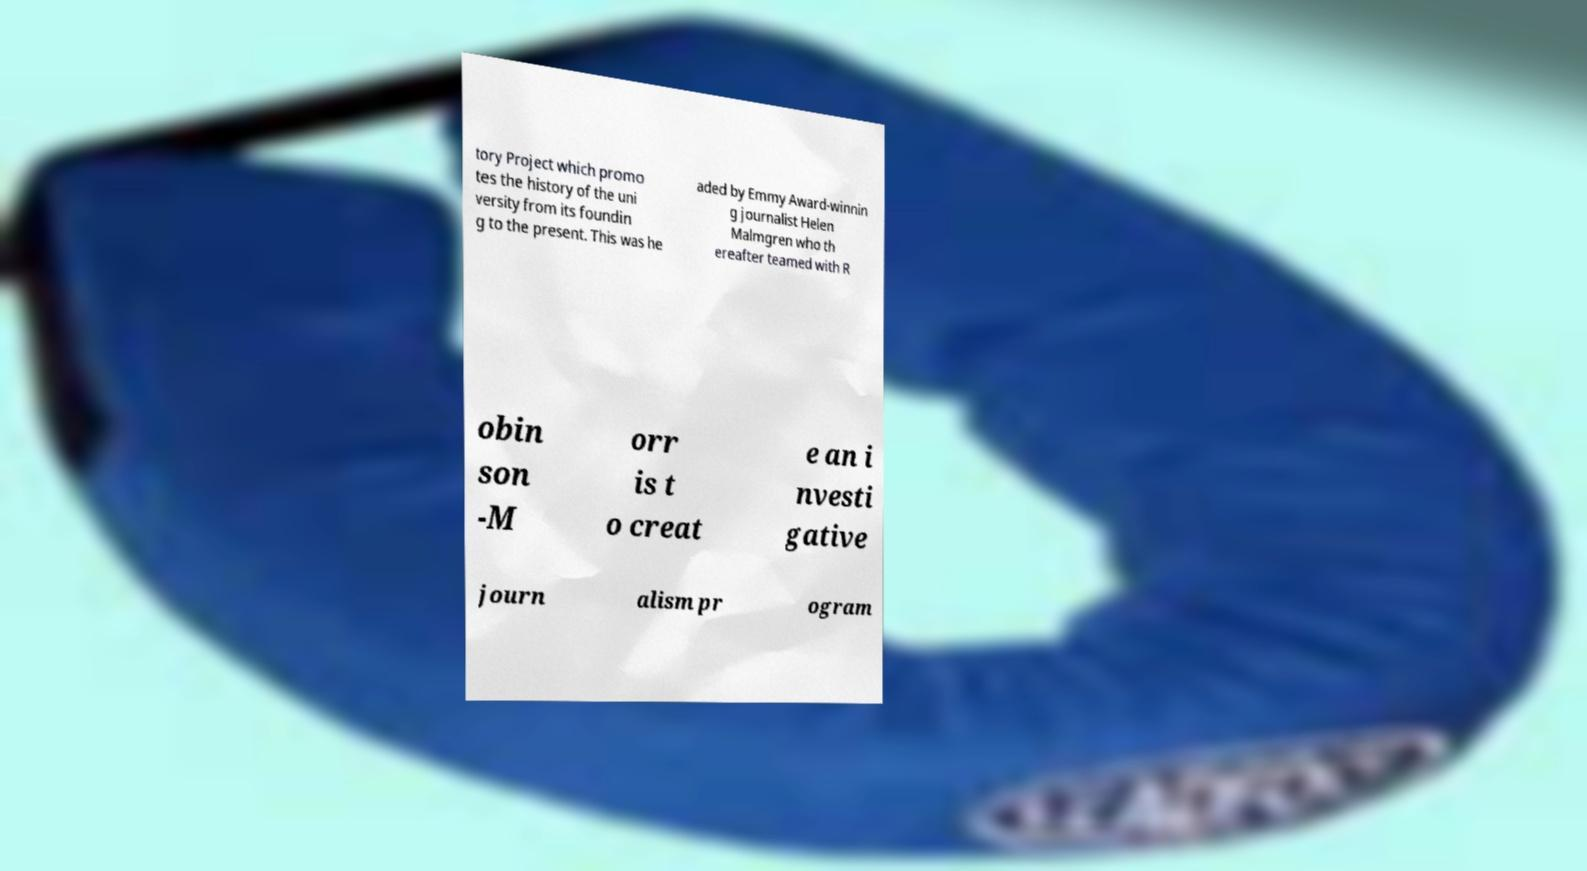For documentation purposes, I need the text within this image transcribed. Could you provide that? tory Project which promo tes the history of the uni versity from its foundin g to the present. This was he aded by Emmy Award-winnin g journalist Helen Malmgren who th ereafter teamed with R obin son -M orr is t o creat e an i nvesti gative journ alism pr ogram 